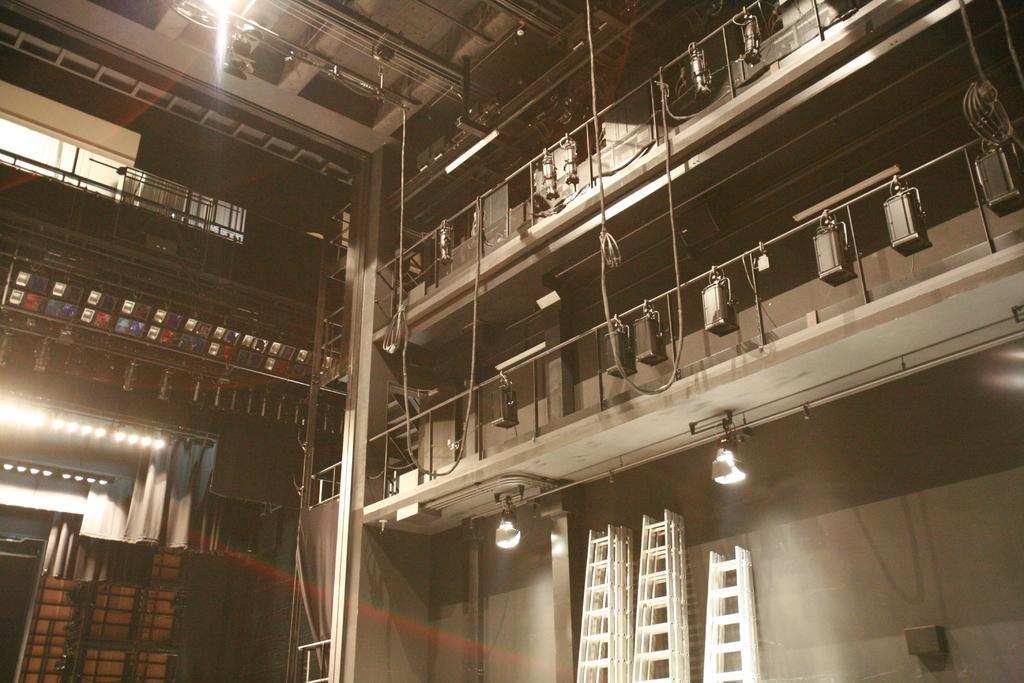Could you give a brief overview of what you see in this image? In this picture this is interior of a building where there are few objects in it. 